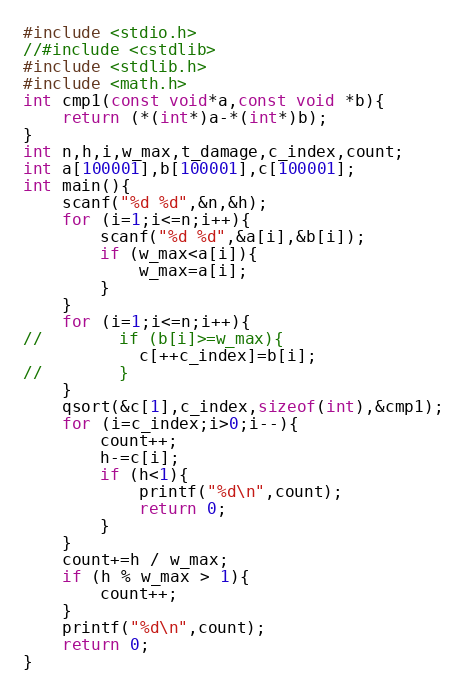<code> <loc_0><loc_0><loc_500><loc_500><_C_>#include <stdio.h>
//#include <cstdlib>
#include <stdlib.h>
#include <math.h>
int cmp1(const void*a,const void *b){
    return (*(int*)a-*(int*)b);
}
int n,h,i,w_max,t_damage,c_index,count;
int a[100001],b[100001],c[100001];
int main(){
    scanf("%d %d",&n,&h);
    for (i=1;i<=n;i++){
        scanf("%d %d",&a[i],&b[i]);
        if (w_max<a[i]){
            w_max=a[i];
        }
    }
    for (i=1;i<=n;i++){
//        if (b[i]>=w_max){
            c[++c_index]=b[i];
//        }
    }
    qsort(&c[1],c_index,sizeof(int),&cmp1);
    for (i=c_index;i>0;i--){
        count++;
        h-=c[i];
        if (h<1){
            printf("%d\n",count);
            return 0;
        }
    }
    count+=h / w_max;
    if (h % w_max > 1){
        count++;
    }
    printf("%d\n",count);
    return 0;
}

</code> 